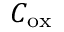<formula> <loc_0><loc_0><loc_500><loc_500>C _ { o x }</formula> 